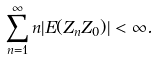<formula> <loc_0><loc_0><loc_500><loc_500>\sum _ { n = 1 } ^ { \infty } n | E ( Z _ { n } Z _ { 0 } ) | < \infty .</formula> 